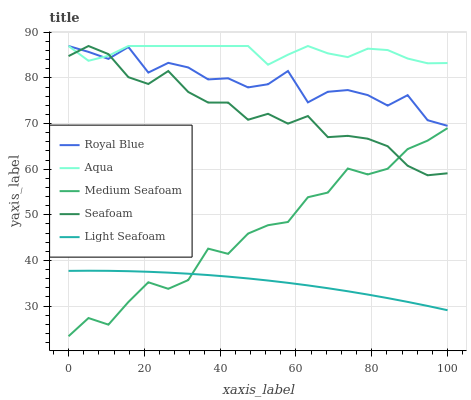Does Light Seafoam have the minimum area under the curve?
Answer yes or no. Yes. Does Aqua have the maximum area under the curve?
Answer yes or no. Yes. Does Aqua have the minimum area under the curve?
Answer yes or no. No. Does Light Seafoam have the maximum area under the curve?
Answer yes or no. No. Is Light Seafoam the smoothest?
Answer yes or no. Yes. Is Royal Blue the roughest?
Answer yes or no. Yes. Is Aqua the smoothest?
Answer yes or no. No. Is Aqua the roughest?
Answer yes or no. No. Does Medium Seafoam have the lowest value?
Answer yes or no. Yes. Does Light Seafoam have the lowest value?
Answer yes or no. No. Does Seafoam have the highest value?
Answer yes or no. Yes. Does Light Seafoam have the highest value?
Answer yes or no. No. Is Light Seafoam less than Royal Blue?
Answer yes or no. Yes. Is Royal Blue greater than Light Seafoam?
Answer yes or no. Yes. Does Seafoam intersect Royal Blue?
Answer yes or no. Yes. Is Seafoam less than Royal Blue?
Answer yes or no. No. Is Seafoam greater than Royal Blue?
Answer yes or no. No. Does Light Seafoam intersect Royal Blue?
Answer yes or no. No. 